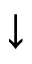Convert formula to latex. <formula><loc_0><loc_0><loc_500><loc_500>\downarrow</formula> 